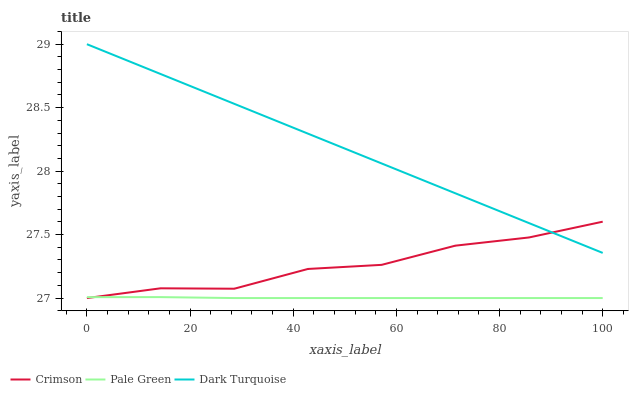Does Pale Green have the minimum area under the curve?
Answer yes or no. Yes. Does Dark Turquoise have the maximum area under the curve?
Answer yes or no. Yes. Does Dark Turquoise have the minimum area under the curve?
Answer yes or no. No. Does Pale Green have the maximum area under the curve?
Answer yes or no. No. Is Dark Turquoise the smoothest?
Answer yes or no. Yes. Is Crimson the roughest?
Answer yes or no. Yes. Is Pale Green the smoothest?
Answer yes or no. No. Is Pale Green the roughest?
Answer yes or no. No. Does Crimson have the lowest value?
Answer yes or no. Yes. Does Dark Turquoise have the lowest value?
Answer yes or no. No. Does Dark Turquoise have the highest value?
Answer yes or no. Yes. Does Pale Green have the highest value?
Answer yes or no. No. Is Pale Green less than Dark Turquoise?
Answer yes or no. Yes. Is Dark Turquoise greater than Pale Green?
Answer yes or no. Yes. Does Crimson intersect Pale Green?
Answer yes or no. Yes. Is Crimson less than Pale Green?
Answer yes or no. No. Is Crimson greater than Pale Green?
Answer yes or no. No. Does Pale Green intersect Dark Turquoise?
Answer yes or no. No. 